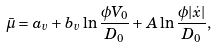Convert formula to latex. <formula><loc_0><loc_0><loc_500><loc_500>\bar { \mu } = a _ { v } + b _ { v } \ln \frac { \phi V _ { 0 } } { D _ { 0 } } + A \ln \frac { \phi | \dot { x } | } { D _ { 0 } } ,</formula> 